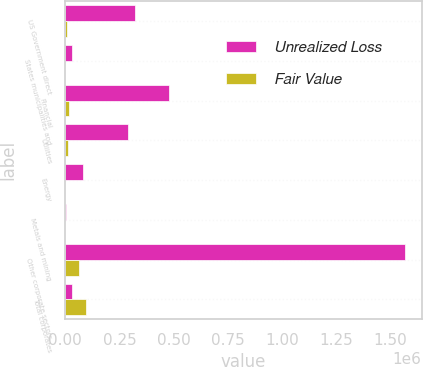Convert chart. <chart><loc_0><loc_0><loc_500><loc_500><stacked_bar_chart><ecel><fcel>US Government direct<fcel>States municipalities and<fcel>Financial<fcel>Utilities<fcel>Energy<fcel>Metals and mining<fcel>Other corporate sectors<fcel>Total corporates<nl><fcel>Unrealized Loss<fcel>321133<fcel>32178<fcel>479669<fcel>290732<fcel>83064<fcel>5936<fcel>1.56427e+06<fcel>32178<nl><fcel>Fair Value<fcel>8553<fcel>1114<fcel>18666<fcel>11000<fcel>1076<fcel>231<fcel>65131<fcel>96104<nl></chart> 